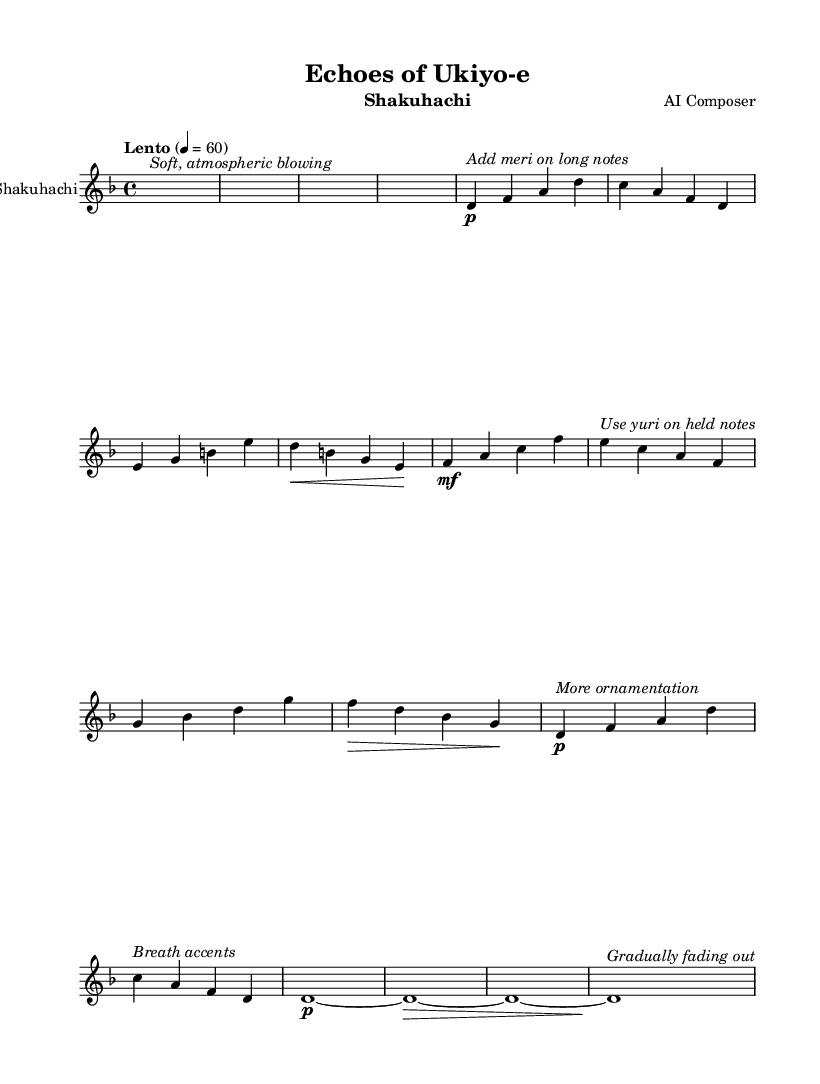What is the key signature of this music? The key signature shows one flat, indicating it is D minor.
Answer: D minor What is the time signature of this music? The time signature is indicated at the beginning of the score, showing 4 beats in each measure.
Answer: 4/4 What is the tempo marking for this piece? The tempo marking "Lento" suggests a slow pace, and it specifies a tempo of 60 beats per minute.
Answer: Lento, 60 How many measures are in the main theme of the piece? By counting the measures in the section labeled "Main theme," there are a total of 8 measures.
Answer: 8 What special technique is suggested for the long notes? The notation specifically calls for "Add meri," indicating a technique used in Japanese music to bend pitches.
Answer: Add meri What does the coda signify in this piece? The coda consists of sustained notes that gradually fade out, showing the conclusion of the piece.
Answer: Gradually fading out What instrument is this sheet music written for? The score header clearly states that the music is composed for the Shakuhachi.
Answer: Shakuhachi 